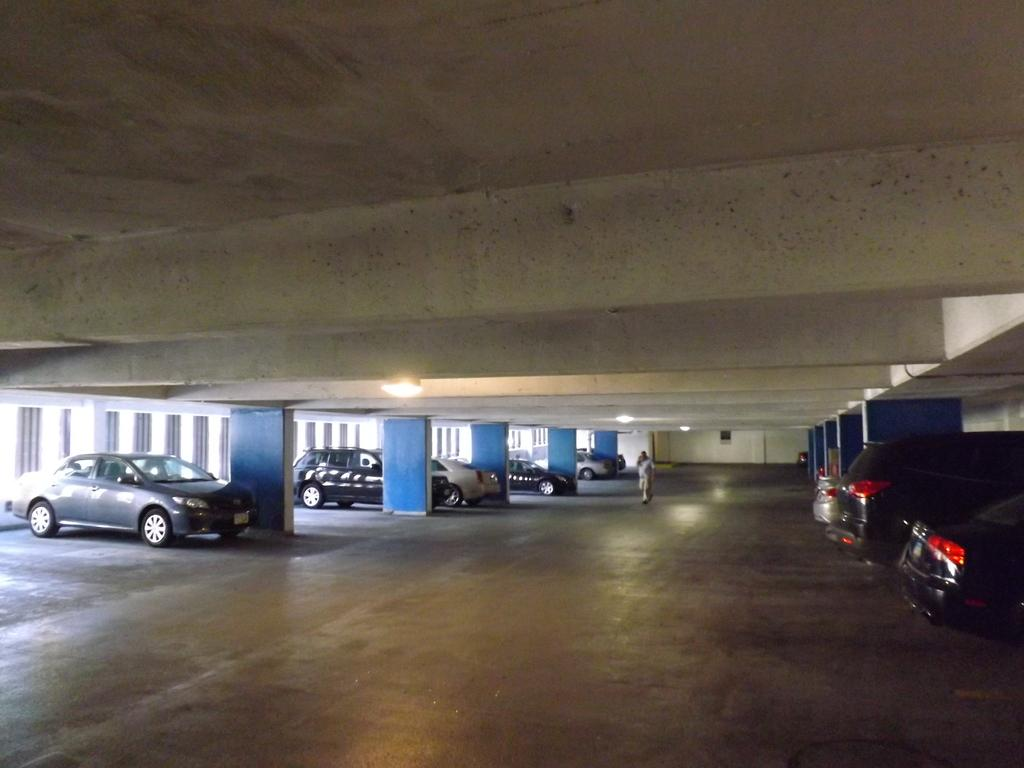What can be seen on the left side of the image? There are cars on the left side of the image. What can be seen on the right side of the image? There are also cars on the right side of the image. Can you describe the person in the image? There is a person walking in the image. What is the color of the wall in the background? The wall in the background is white. How low can the wall in the image be moved? The wall in the image cannot be moved, as it is a stationary background element. 